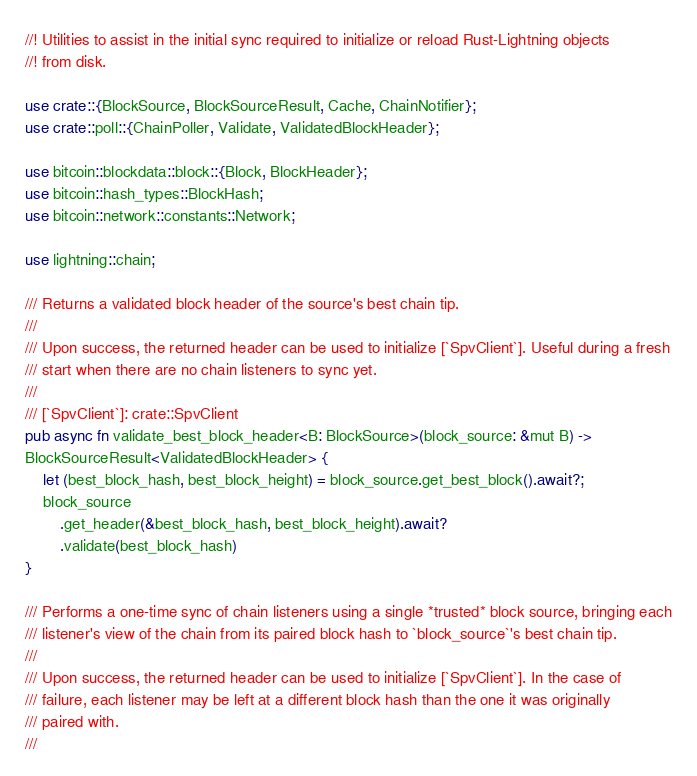<code> <loc_0><loc_0><loc_500><loc_500><_Rust_>//! Utilities to assist in the initial sync required to initialize or reload Rust-Lightning objects
//! from disk.

use crate::{BlockSource, BlockSourceResult, Cache, ChainNotifier};
use crate::poll::{ChainPoller, Validate, ValidatedBlockHeader};

use bitcoin::blockdata::block::{Block, BlockHeader};
use bitcoin::hash_types::BlockHash;
use bitcoin::network::constants::Network;

use lightning::chain;

/// Returns a validated block header of the source's best chain tip.
///
/// Upon success, the returned header can be used to initialize [`SpvClient`]. Useful during a fresh
/// start when there are no chain listeners to sync yet.
///
/// [`SpvClient`]: crate::SpvClient
pub async fn validate_best_block_header<B: BlockSource>(block_source: &mut B) ->
BlockSourceResult<ValidatedBlockHeader> {
	let (best_block_hash, best_block_height) = block_source.get_best_block().await?;
	block_source
		.get_header(&best_block_hash, best_block_height).await?
		.validate(best_block_hash)
}

/// Performs a one-time sync of chain listeners using a single *trusted* block source, bringing each
/// listener's view of the chain from its paired block hash to `block_source`'s best chain tip.
///
/// Upon success, the returned header can be used to initialize [`SpvClient`]. In the case of
/// failure, each listener may be left at a different block hash than the one it was originally
/// paired with.
///</code> 